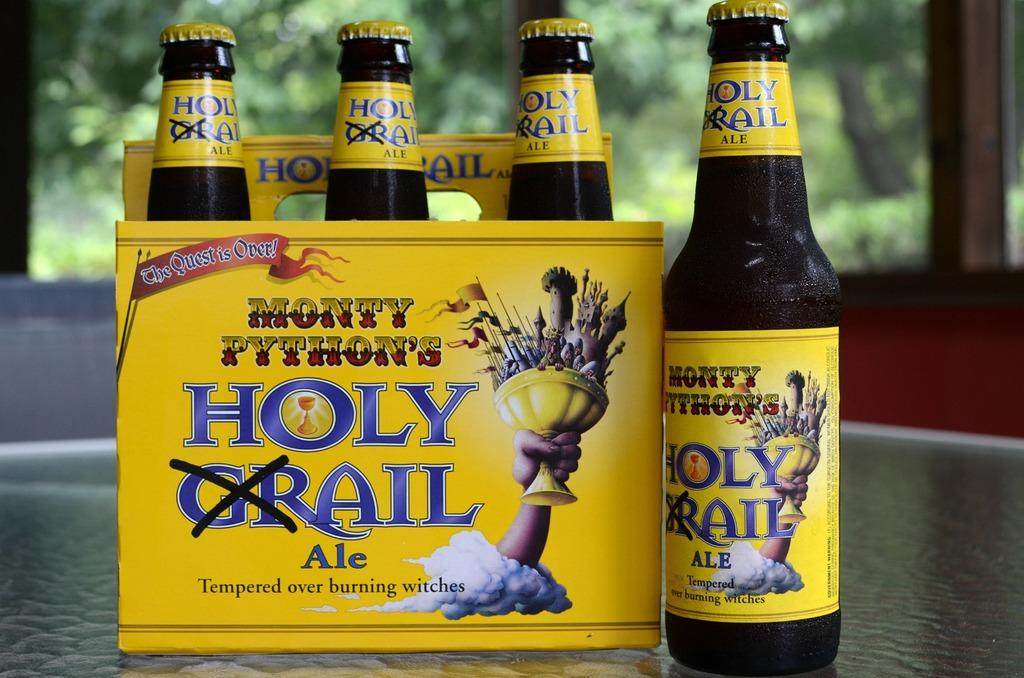<image>
Provide a brief description of the given image. Six pack of holy grail ale the quest is over drinks 